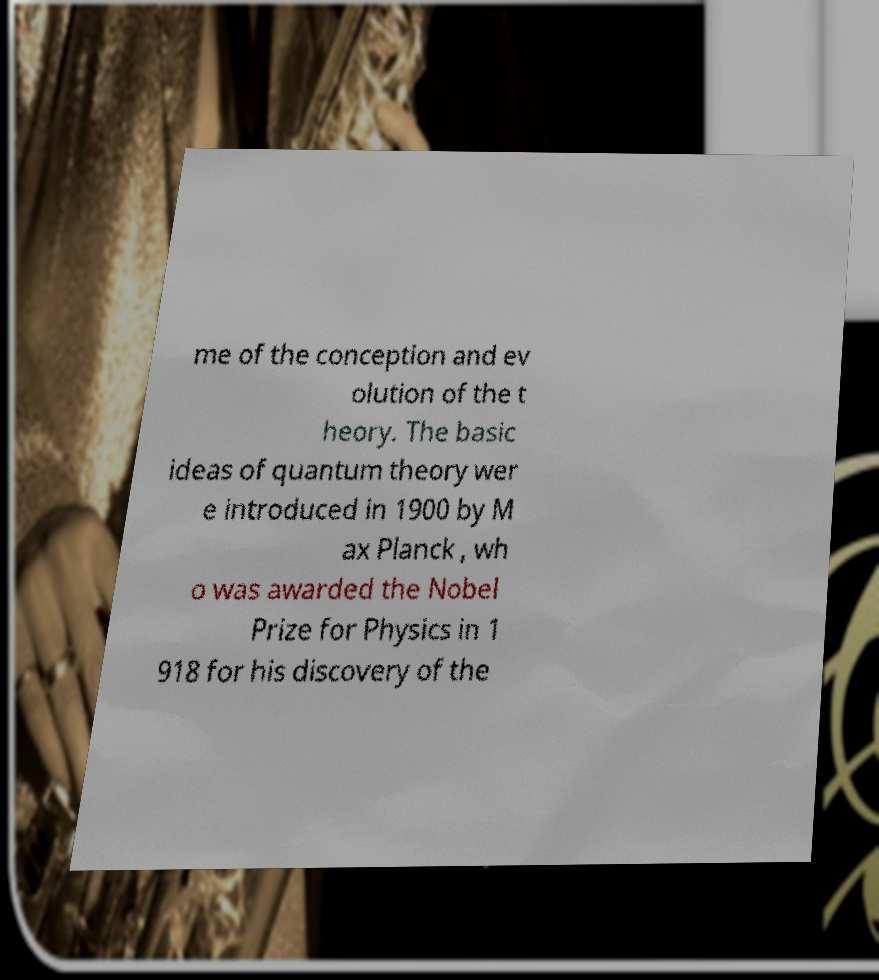I need the written content from this picture converted into text. Can you do that? me of the conception and ev olution of the t heory. The basic ideas of quantum theory wer e introduced in 1900 by M ax Planck , wh o was awarded the Nobel Prize for Physics in 1 918 for his discovery of the 